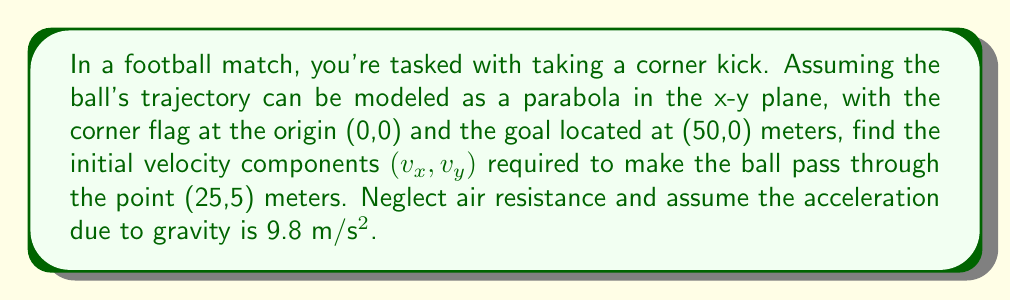Can you solve this math problem? Let's approach this step-by-step:

1) The trajectory of the ball can be described by the equations of motion for projectile motion:

   $$x = v_x t$$
   $$y = v_y t - \frac{1}{2}gt^2$$

   where $g = 9.8$ m/s².

2) We know the ball passes through the point (25,5) at some time $t$. Let's use this information:

   $$25 = v_x t$$
   $$5 = v_y t - \frac{1}{2}(9.8)t^2$$

3) From the first equation, we can express $t$ in terms of $v_x$:

   $$t = \frac{25}{v_x}$$

4) Substitute this into the second equation:

   $$5 = v_y (\frac{25}{v_x}) - \frac{1}{2}(9.8)(\frac{25}{v_x})^2$$

5) Multiply both sides by $v_x^2$:

   $$5v_x^2 = 25v_xv_y - \frac{1}{2}(9.8)(625)$$

6) Simplify:

   $$5v_x^2 = 25v_xv_y - 3062.5$$

7) Rearrange:

   $$25v_xv_y = 5v_x^2 + 3062.5$$

8) Divide both sides by $25v_x$:

   $$v_y = \frac{v_x}{5} + \frac{122.5}{v_x}$$

This equation relates $v_y$ to $v_x$. There are infinitely many solutions, but a reasonable choice for a corner kick might be $v_x = 15$ m/s.

9) If $v_x = 15$ m/s, then:

   $$v_y = \frac{15}{5} + \frac{122.5}{15} = 3 + 8.17 = 11.17$$ m/s

Therefore, one possible solution is $v_x = 15$ m/s and $v_y = 11.17$ m/s.
Answer: $(v_x, v_y) = (15, 11.17)$ m/s 